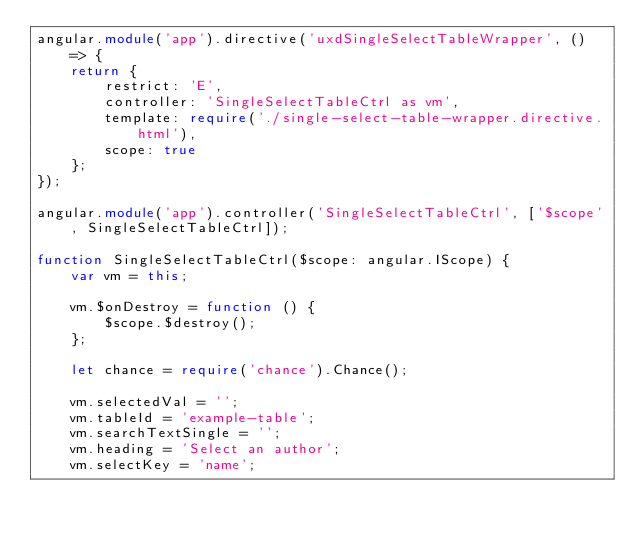Convert code to text. <code><loc_0><loc_0><loc_500><loc_500><_TypeScript_>angular.module('app').directive('uxdSingleSelectTableWrapper', () => {
    return {
        restrict: 'E',
        controller: 'SingleSelectTableCtrl as vm',
        template: require('./single-select-table-wrapper.directive.html'),
        scope: true
    };
});

angular.module('app').controller('SingleSelectTableCtrl', ['$scope', SingleSelectTableCtrl]);

function SingleSelectTableCtrl($scope: angular.IScope) {
    var vm = this;

    vm.$onDestroy = function () {
        $scope.$destroy();
    };

    let chance = require('chance').Chance();

    vm.selectedVal = '';
    vm.tableId = 'example-table';
    vm.searchTextSingle = '';
    vm.heading = 'Select an author';
    vm.selectKey = 'name';</code> 